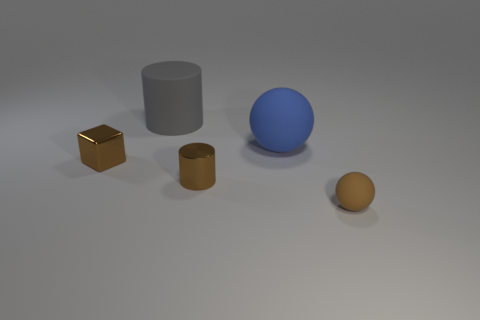How many tiny things have the same shape as the big blue rubber thing?
Keep it short and to the point. 1. There is a brown cube that is made of the same material as the tiny cylinder; what is its size?
Ensure brevity in your answer.  Small. There is a rubber ball behind the sphere in front of the tiny metallic cylinder; what is its color?
Offer a terse response. Blue. There is a small matte thing; does it have the same shape as the brown object on the left side of the small brown metallic cylinder?
Your answer should be very brief. No. How many brown cylinders have the same size as the shiny block?
Offer a very short reply. 1. There is a big thing that is the same shape as the tiny brown matte thing; what material is it?
Ensure brevity in your answer.  Rubber. Do the ball that is in front of the tiny cylinder and the thing behind the big ball have the same color?
Provide a short and direct response. No. There is a metallic object to the right of the brown block; what shape is it?
Give a very brief answer. Cylinder. What is the color of the tiny rubber object?
Your response must be concise. Brown. The brown object that is the same material as the big gray thing is what shape?
Your answer should be compact. Sphere. 